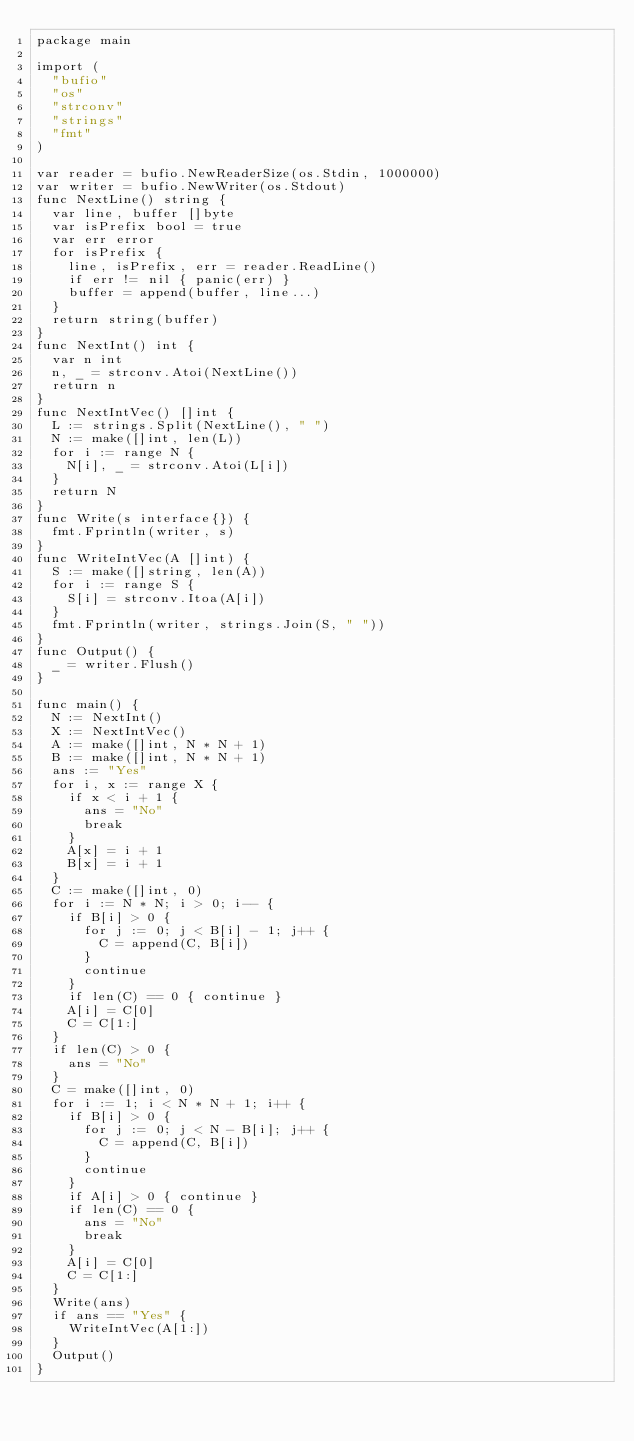<code> <loc_0><loc_0><loc_500><loc_500><_Go_>package main

import (
  "bufio"
  "os"
  "strconv"
  "strings"
  "fmt"
)

var reader = bufio.NewReaderSize(os.Stdin, 1000000)
var writer = bufio.NewWriter(os.Stdout)
func NextLine() string {
  var line, buffer []byte
  var isPrefix bool = true
  var err error
  for isPrefix {
    line, isPrefix, err = reader.ReadLine()
    if err != nil { panic(err) }
    buffer = append(buffer, line...)
  }
  return string(buffer)
}
func NextInt() int {
  var n int
  n, _ = strconv.Atoi(NextLine())
  return n
}
func NextIntVec() []int {
  L := strings.Split(NextLine(), " ")
  N := make([]int, len(L))
  for i := range N {
    N[i], _ = strconv.Atoi(L[i])
  }
  return N
}
func Write(s interface{}) {
  fmt.Fprintln(writer, s)
}
func WriteIntVec(A []int) {
  S := make([]string, len(A))
  for i := range S {
    S[i] = strconv.Itoa(A[i])
  }
  fmt.Fprintln(writer, strings.Join(S, " "))
}
func Output() {
  _ = writer.Flush()
}

func main() {
  N := NextInt()
  X := NextIntVec()
  A := make([]int, N * N + 1)
  B := make([]int, N * N + 1)
  ans := "Yes"
  for i, x := range X {
    if x < i + 1 {
      ans = "No"
      break
    }
    A[x] = i + 1
    B[x] = i + 1
  }
  C := make([]int, 0)
  for i := N * N; i > 0; i-- {
    if B[i] > 0 {
      for j := 0; j < B[i] - 1; j++ {
        C = append(C, B[i])
      }
      continue
    }
    if len(C) == 0 { continue }
    A[i] = C[0]
    C = C[1:]
  }
  if len(C) > 0 {
    ans = "No"
  }
  C = make([]int, 0)
  for i := 1; i < N * N + 1; i++ {
    if B[i] > 0 {
      for j := 0; j < N - B[i]; j++ {
        C = append(C, B[i])
      }
      continue
    }
    if A[i] > 0 { continue }
    if len(C) == 0 {
      ans = "No"
      break
    }
    A[i] = C[0]
    C = C[1:]
  }
  Write(ans)
  if ans == "Yes" {
    WriteIntVec(A[1:])
  }
  Output()
}</code> 